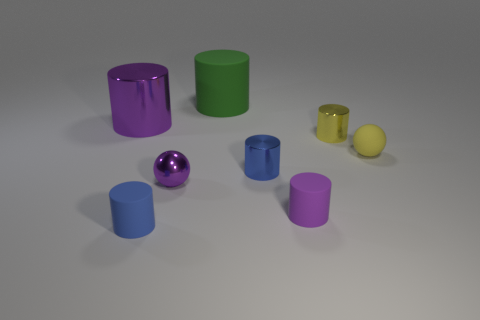Are there any patterns or symmetry in the arrangement of the objects? At a glance, the objects seem to be placed randomly; however, upon closer inspection, it's evident that there's no intentional pattern or symmetry in their arrangement. 